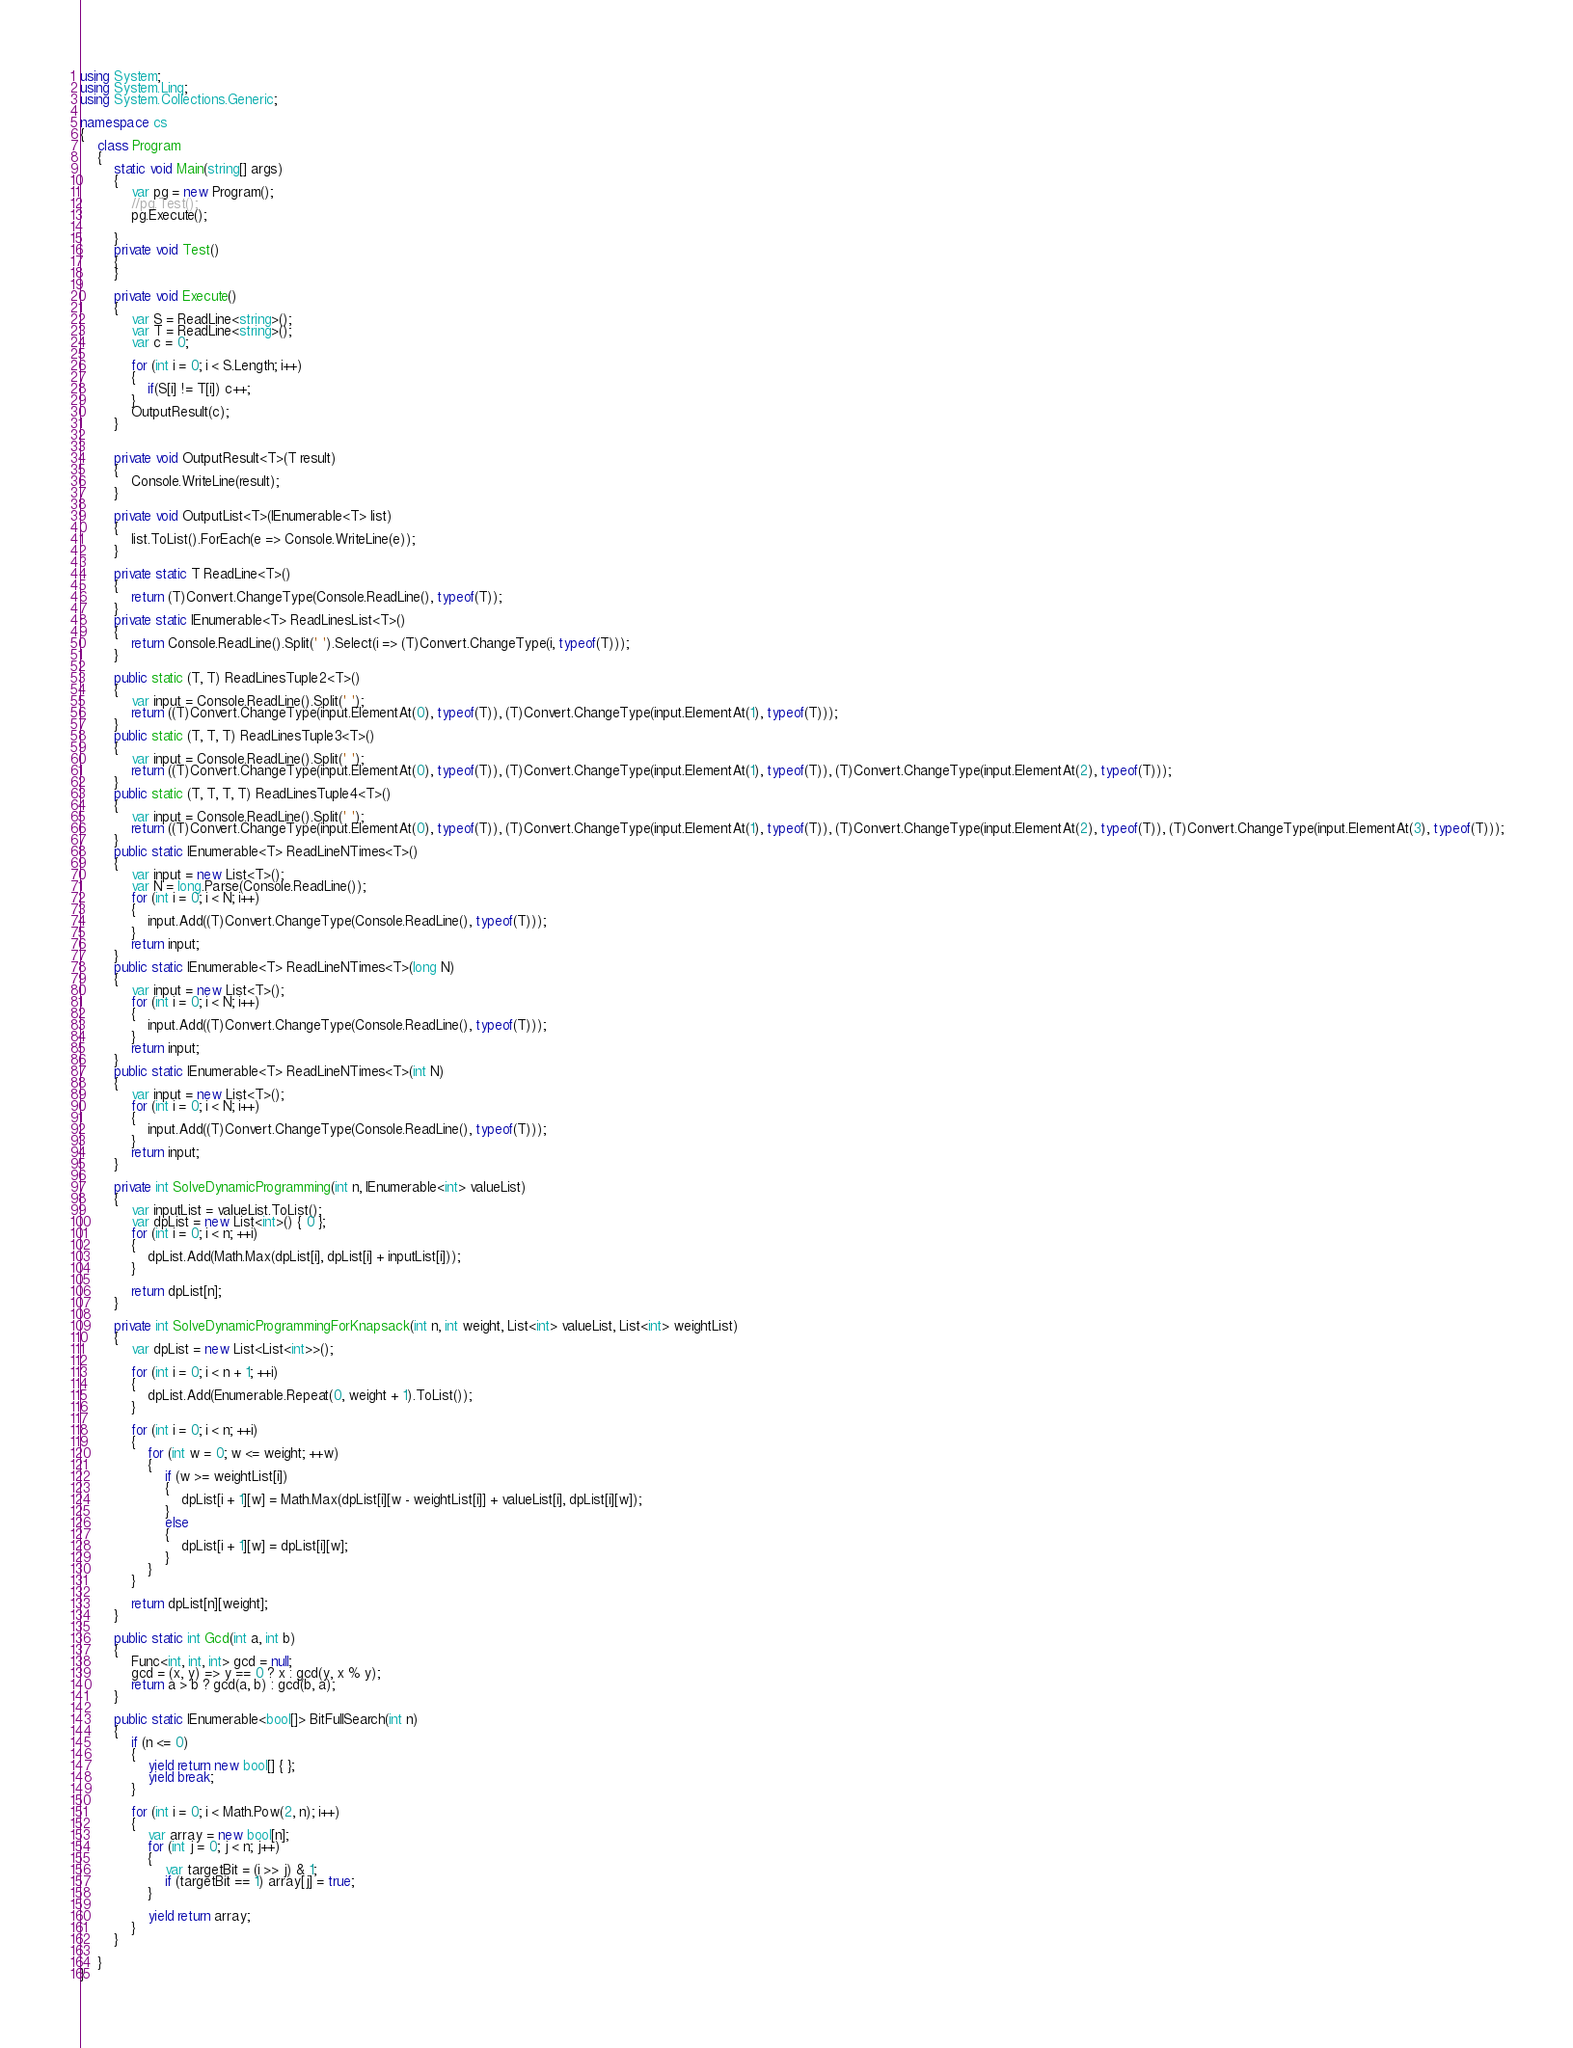Convert code to text. <code><loc_0><loc_0><loc_500><loc_500><_C#_>using System;
using System.Linq;
using System.Collections.Generic;

namespace cs
{
    class Program
    {
        static void Main(string[] args)
        {
            var pg = new Program();
            //pg.Test();
            pg.Execute();

        }
        private void Test()
        {
        }

        private void Execute()
        {
            var S = ReadLine<string>();
            var T = ReadLine<string>();
            var c = 0;

            for (int i = 0; i < S.Length; i++)
            {   
                if(S[i] != T[i]) c++;
            }
            OutputResult(c);
        }


        private void OutputResult<T>(T result)
        {
            Console.WriteLine(result);
        }

        private void OutputList<T>(IEnumerable<T> list)
        {
            list.ToList().ForEach(e => Console.WriteLine(e));
        }

        private static T ReadLine<T>()
        {
            return (T)Convert.ChangeType(Console.ReadLine(), typeof(T));
        }
        private static IEnumerable<T> ReadLinesList<T>()
        {
            return Console.ReadLine().Split(' ').Select(i => (T)Convert.ChangeType(i, typeof(T)));
        }

        public static (T, T) ReadLinesTuple2<T>()
        {
            var input = Console.ReadLine().Split(' ');
            return ((T)Convert.ChangeType(input.ElementAt(0), typeof(T)), (T)Convert.ChangeType(input.ElementAt(1), typeof(T)));
        }
        public static (T, T, T) ReadLinesTuple3<T>()
        {
            var input = Console.ReadLine().Split(' ');
            return ((T)Convert.ChangeType(input.ElementAt(0), typeof(T)), (T)Convert.ChangeType(input.ElementAt(1), typeof(T)), (T)Convert.ChangeType(input.ElementAt(2), typeof(T)));
        }
        public static (T, T, T, T) ReadLinesTuple4<T>()
        {
            var input = Console.ReadLine().Split(' ');
            return ((T)Convert.ChangeType(input.ElementAt(0), typeof(T)), (T)Convert.ChangeType(input.ElementAt(1), typeof(T)), (T)Convert.ChangeType(input.ElementAt(2), typeof(T)), (T)Convert.ChangeType(input.ElementAt(3), typeof(T)));
        }
        public static IEnumerable<T> ReadLineNTimes<T>()
        {
            var input = new List<T>();
            var N = long.Parse(Console.ReadLine());
            for (int i = 0; i < N; i++)
            {
                input.Add((T)Convert.ChangeType(Console.ReadLine(), typeof(T)));
            }
            return input;
        }
        public static IEnumerable<T> ReadLineNTimes<T>(long N)
        {
            var input = new List<T>();
            for (int i = 0; i < N; i++)
            {
                input.Add((T)Convert.ChangeType(Console.ReadLine(), typeof(T)));
            }
            return input;
        }
        public static IEnumerable<T> ReadLineNTimes<T>(int N)
        {
            var input = new List<T>();
            for (int i = 0; i < N; i++)
            {
                input.Add((T)Convert.ChangeType(Console.ReadLine(), typeof(T)));
            }
            return input;
        }

        private int SolveDynamicProgramming(int n, IEnumerable<int> valueList)
        {
            var inputList = valueList.ToList();
            var dpList = new List<int>() { 0 };
            for (int i = 0; i < n; ++i)
            {
                dpList.Add(Math.Max(dpList[i], dpList[i] + inputList[i]));
            }

            return dpList[n];
        }

        private int SolveDynamicProgrammingForKnapsack(int n, int weight, List<int> valueList, List<int> weightList)
        {
            var dpList = new List<List<int>>();

            for (int i = 0; i < n + 1; ++i)
            {
                dpList.Add(Enumerable.Repeat(0, weight + 1).ToList());
            }

            for (int i = 0; i < n; ++i)
            {
                for (int w = 0; w <= weight; ++w)
                {
                    if (w >= weightList[i])
                    {
                        dpList[i + 1][w] = Math.Max(dpList[i][w - weightList[i]] + valueList[i], dpList[i][w]);
                    }
                    else
                    {
                        dpList[i + 1][w] = dpList[i][w];
                    }
                }
            }

            return dpList[n][weight];
        }

        public static int Gcd(int a, int b)
        {
            Func<int, int, int> gcd = null;
            gcd = (x, y) => y == 0 ? x : gcd(y, x % y);
            return a > b ? gcd(a, b) : gcd(b, a);
        }

        public static IEnumerable<bool[]> BitFullSearch(int n)
        {
            if (n <= 0)
            {
                yield return new bool[] { };
                yield break;
            }

            for (int i = 0; i < Math.Pow(2, n); i++)
            {
                var array = new bool[n];
                for (int j = 0; j < n; j++)
                {
                    var targetBit = (i >> j) & 1;
                    if (targetBit == 1) array[j] = true;
                }

                yield return array;
            }
        }

    }
}
</code> 